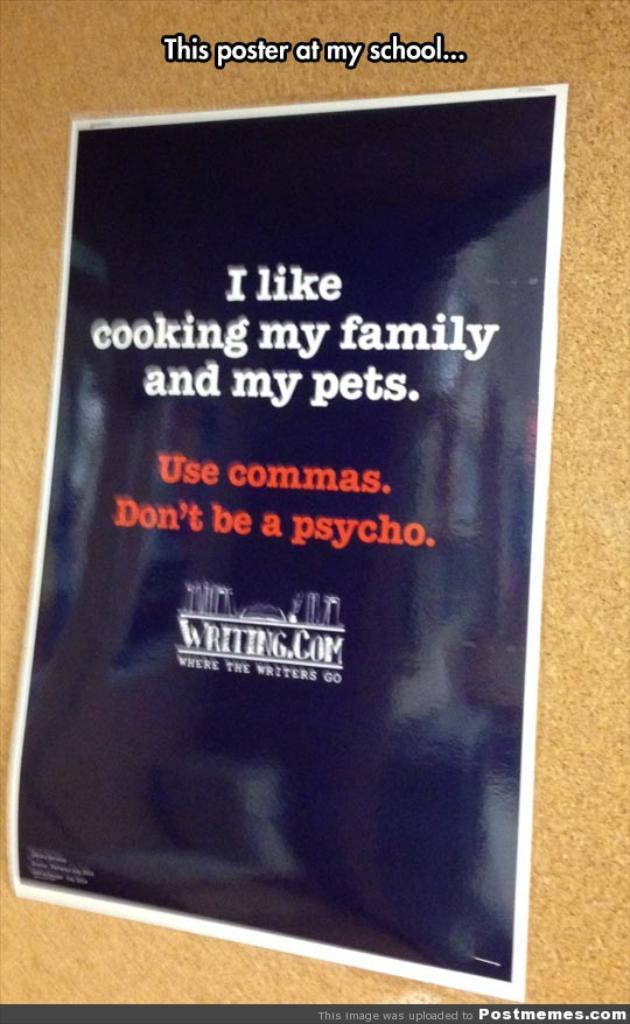<image>
Relay a brief, clear account of the picture shown. a poster reading I like Cooking My Family and My pets 